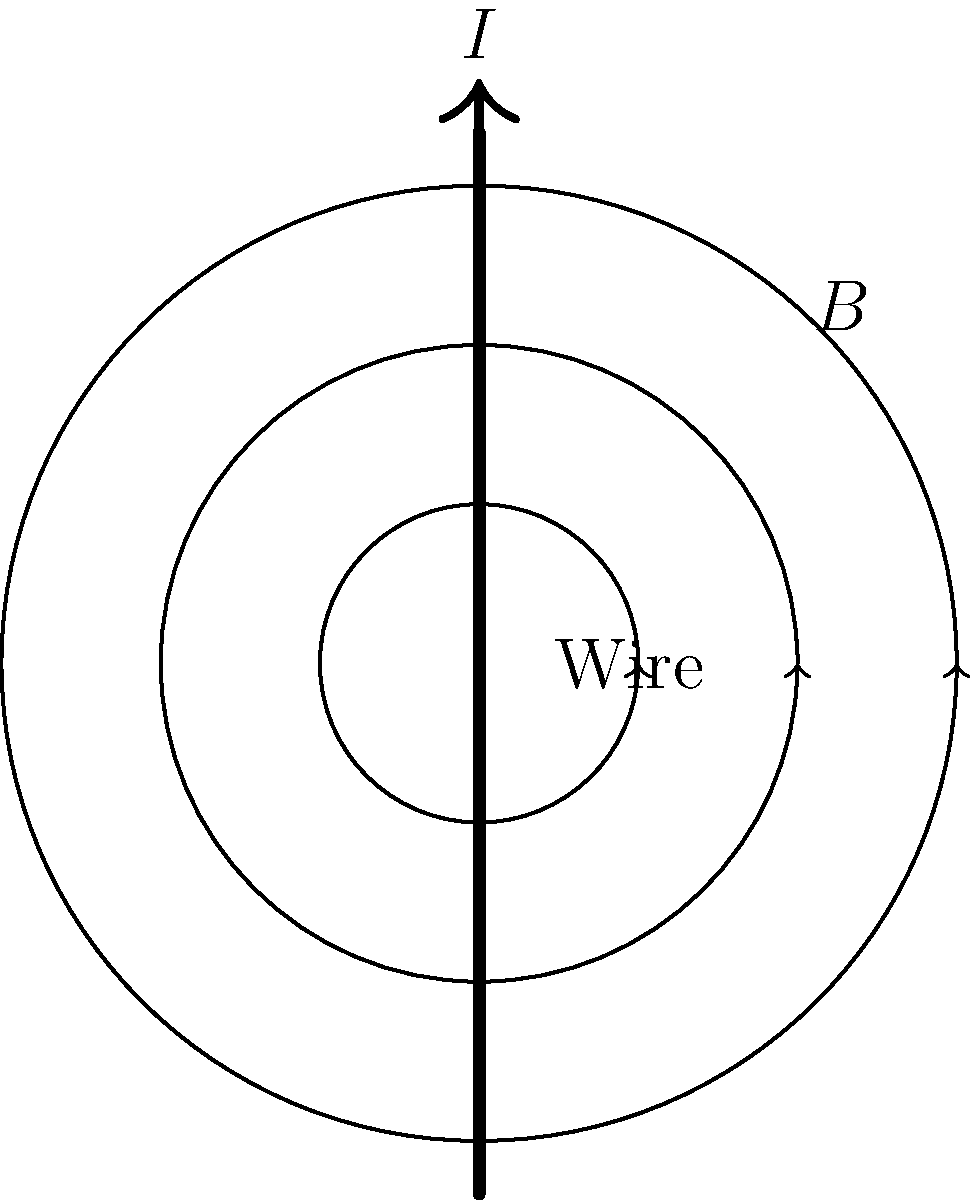A straight wire carries a current $I$ as shown in the figure. At a distance $r$ from the wire, the magnetic field strength $B$ is measured. If the current is doubled and the distance is halved, how will the magnetic field strength change? Express your answer as a multiple of the original field strength. To solve this problem, let's follow these steps:

1) The magnetic field strength $B$ around a straight current-carrying wire is given by the formula:

   $$B = \frac{\mu_0 I}{2\pi r}$$

   where $\mu_0$ is the permeability of free space, $I$ is the current, and $r$ is the distance from the wire.

2) Let's call the initial magnetic field strength $B_1$ and the new magnetic field strength $B_2$.

3) Initially:
   $$B_1 = \frac{\mu_0 I}{2\pi r}$$

4) When the current is doubled and the distance is halved:
   $$B_2 = \frac{\mu_0 (2I)}{2\pi (r/2)}$$

5) Simplify $B_2$:
   $$B_2 = \frac{2\mu_0 I}{2\pi (r/2)} = \frac{4\mu_0 I}{2\pi r}$$

6) Compare $B_2$ to $B_1$:
   $$\frac{B_2}{B_1} = \frac{4\mu_0 I}{2\pi r} \div \frac{\mu_0 I}{2\pi r} = 4$$

Therefore, the new magnetic field strength is 4 times the original field strength.
Answer: 4 times the original field strength 